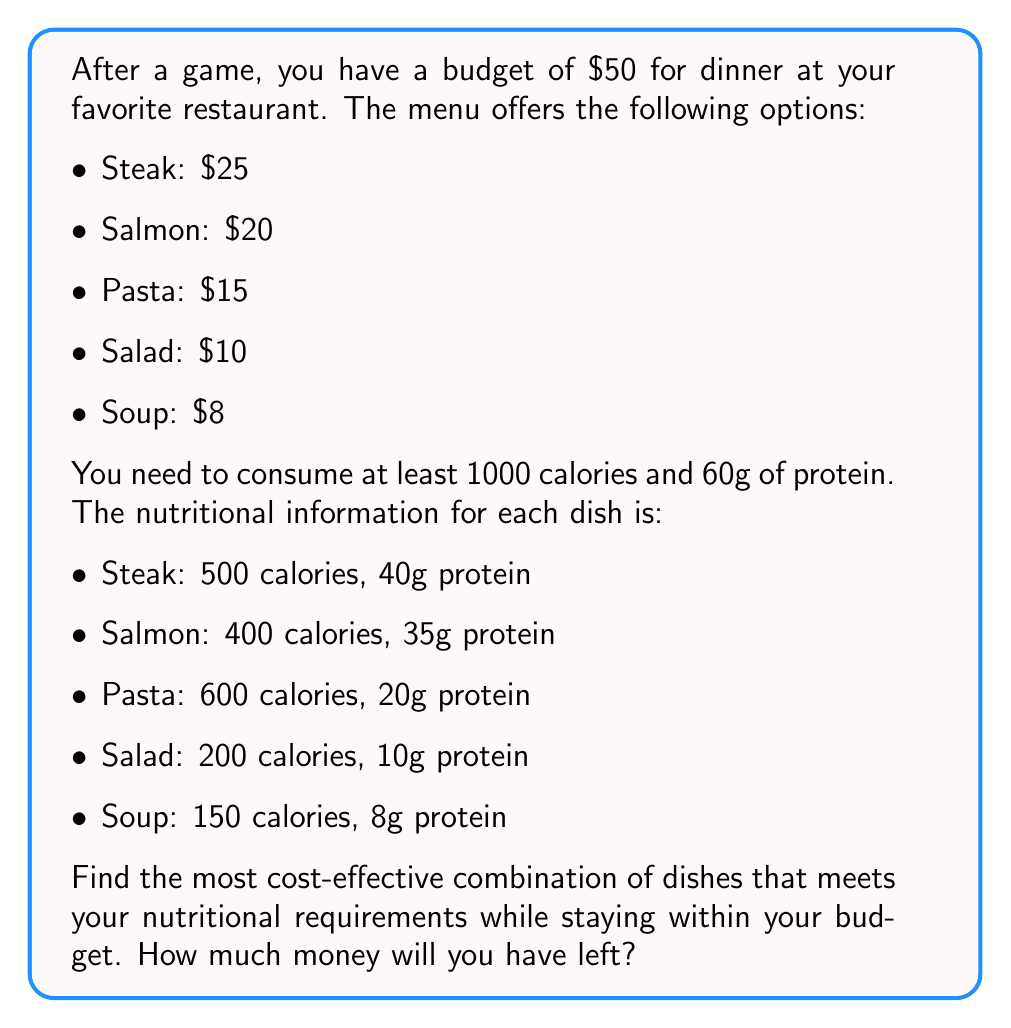Can you answer this question? Let's approach this step-by-step:

1) First, we need to set up variables for each dish:
   Let $s$ = number of steaks
   Let $f$ = number of salmon fillets
   Let $p$ = number of pasta dishes
   Let $a$ = number of salads
   Let $o$ = number of soups

2) Now, we can set up our constraints:
   Budget constraint: $25s + 20f + 15p + 10a + 8o \leq 50$
   Calorie constraint: $500s + 400f + 600p + 200a + 150o \geq 1000$
   Protein constraint: $40s + 35f + 20p + 10a + 8o \geq 60$

3) We also need to consider that we can't order partial dishes, so all variables must be non-negative integers.

4) Given that we're looking for the most cost-effective option, we should start with the dishes that provide the most calories and protein per dollar:

   Pasta: 40 calories/$, 1.33g protein/$
   Salmon: 20 calories/$, 1.75g protein/$
   Steak: 20 calories/$, 1.6g protein/$
   Salad: 20 calories/$, 1g protein/$
   Soup: 18.75 calories/$, 1g protein/$

5) Let's start with one pasta dish ($p = 1$):
   This gives us 600 calories and 20g protein for $15.

6) We still need 400 calories and 40g protein. Salmon seems to be the best option now:
   Adding one salmon ($f = 1$) gives us an additional 400 calories and 35g protein for $20.

7) We now have 1000 calories and 55g protein, spending $35. We still need 5g protein.

8) A soup ($o = 1$) will provide the remaining protein and some extra calories for $8.

9) Our final combination is: 1 pasta, 1 salmon, and 1 soup.
   Total cost: $15 + $20 + $8 = $43
   Total calories: 600 + 400 + 150 = 1150
   Total protein: 20g + 35g + 8g = 63g

10) Money left: $50 - $43 = $7

This combination meets all requirements and leaves us with the most money.
Answer: $7 